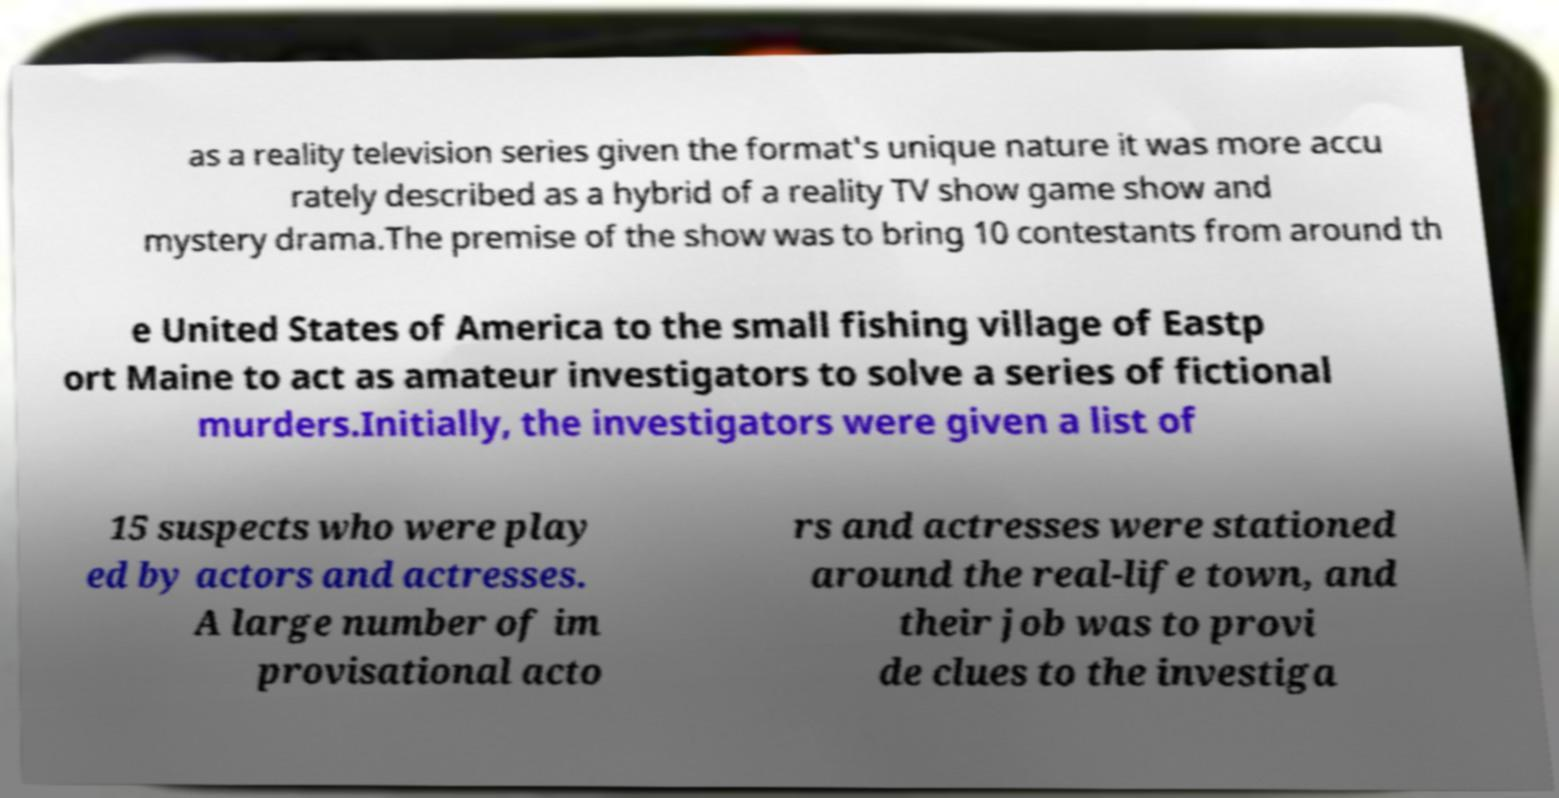There's text embedded in this image that I need extracted. Can you transcribe it verbatim? as a reality television series given the format's unique nature it was more accu rately described as a hybrid of a reality TV show game show and mystery drama.The premise of the show was to bring 10 contestants from around th e United States of America to the small fishing village of Eastp ort Maine to act as amateur investigators to solve a series of fictional murders.Initially, the investigators were given a list of 15 suspects who were play ed by actors and actresses. A large number of im provisational acto rs and actresses were stationed around the real-life town, and their job was to provi de clues to the investiga 